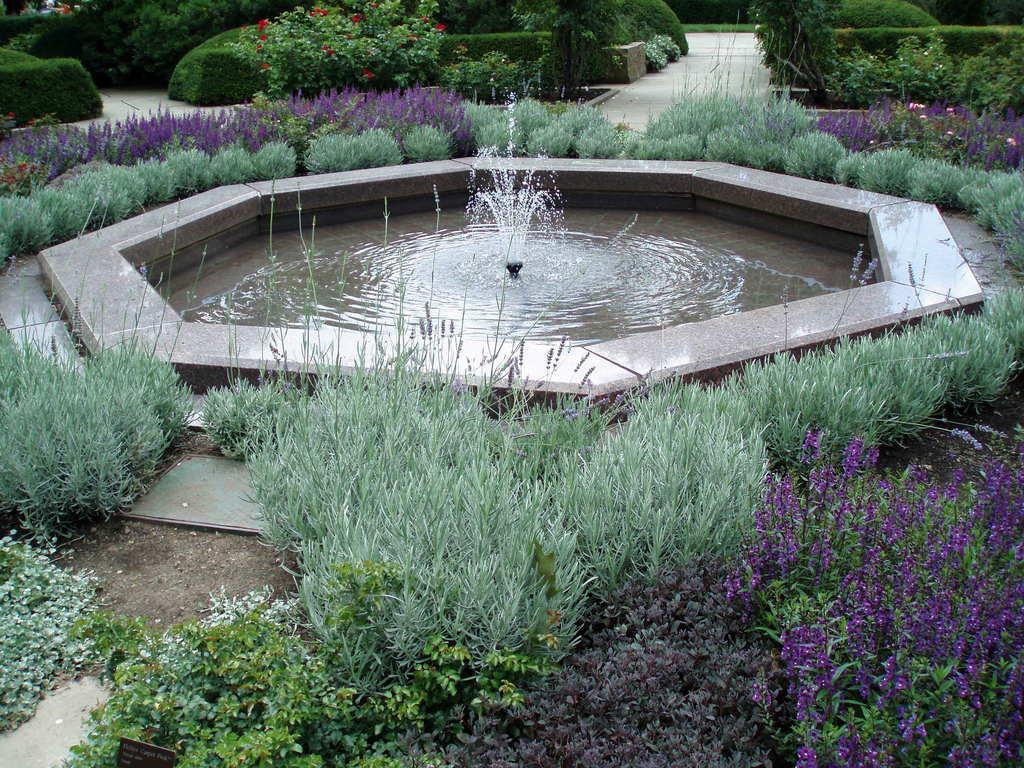Can you describe this image briefly? In this picture we can see few flowers, plants and shrubs, and also we can find water fountain. 